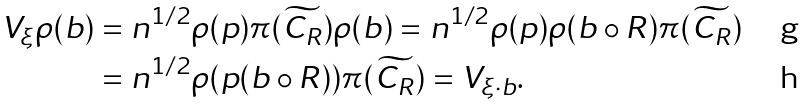Convert formula to latex. <formula><loc_0><loc_0><loc_500><loc_500>V _ { \xi } \rho ( b ) & = n ^ { 1 / 2 } \rho ( p ) \pi ( \widetilde { C _ { R } } ) \rho ( b ) = n ^ { 1 / 2 } \rho ( p ) \rho ( b \circ R ) \pi ( \widetilde { C _ { R } } ) \\ & = n ^ { 1 / 2 } \rho ( p ( b \circ R ) ) \pi ( \widetilde { C _ { R } } ) = V _ { \xi \cdot b } .</formula> 